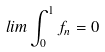Convert formula to latex. <formula><loc_0><loc_0><loc_500><loc_500>l i m \int _ { 0 } ^ { 1 } f _ { n } = 0</formula> 